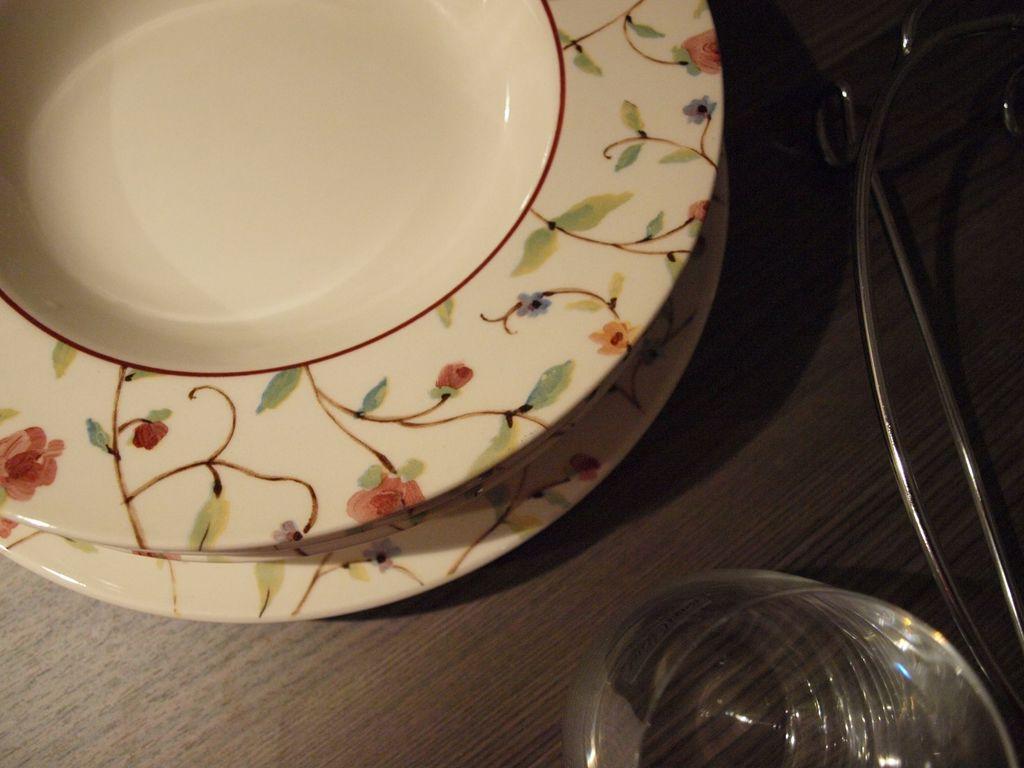In one or two sentences, can you explain what this image depicts? In this picture we can see a table,on table we can see plates and bowl. 